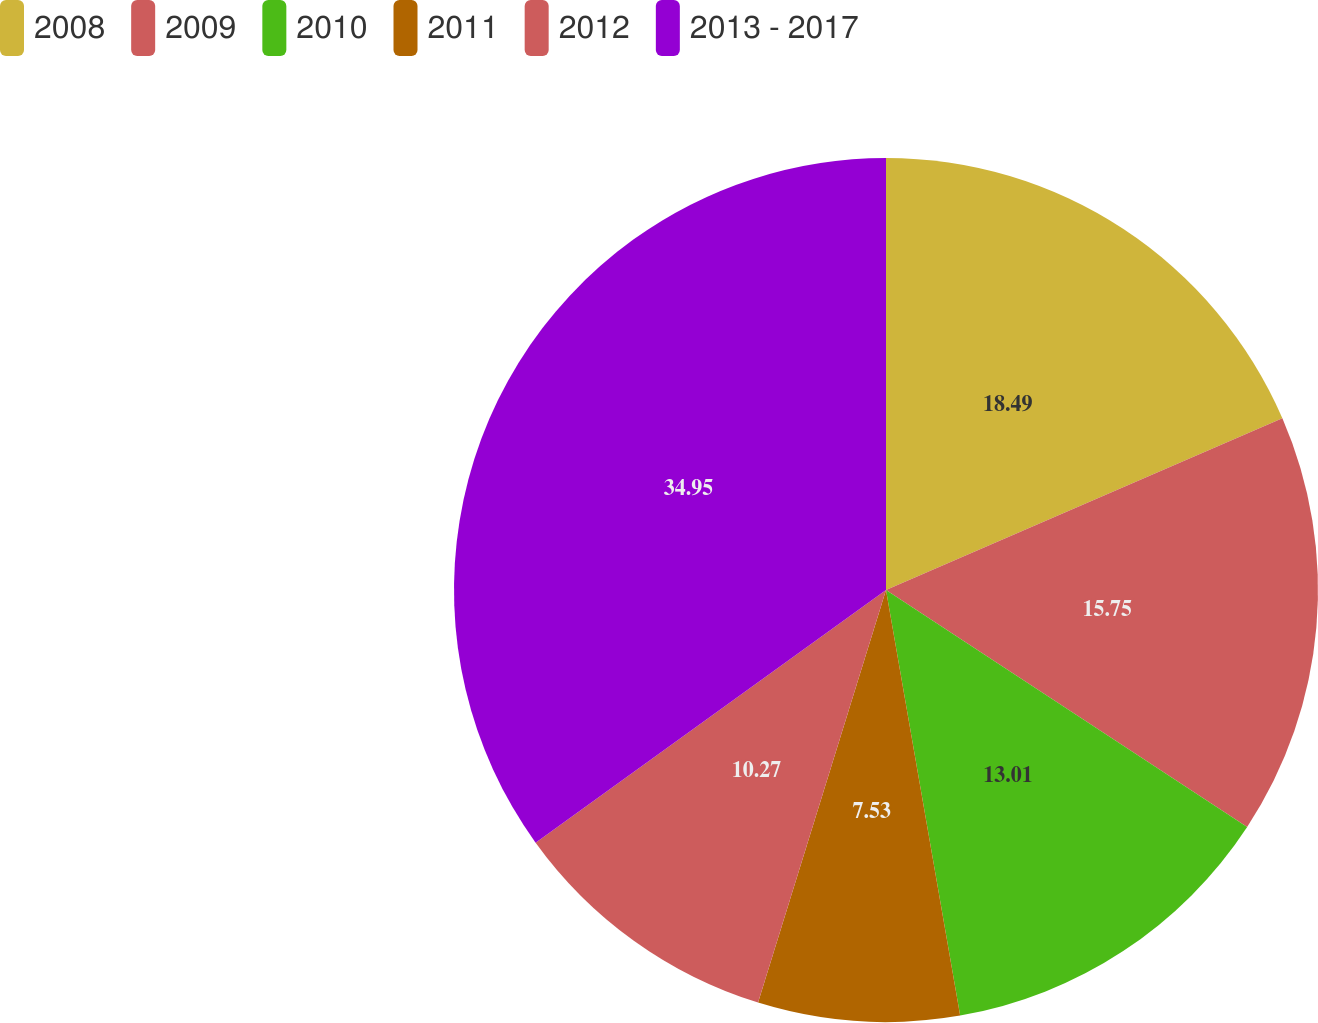Convert chart. <chart><loc_0><loc_0><loc_500><loc_500><pie_chart><fcel>2008<fcel>2009<fcel>2010<fcel>2011<fcel>2012<fcel>2013 - 2017<nl><fcel>18.49%<fcel>15.75%<fcel>13.01%<fcel>7.53%<fcel>10.27%<fcel>34.94%<nl></chart> 